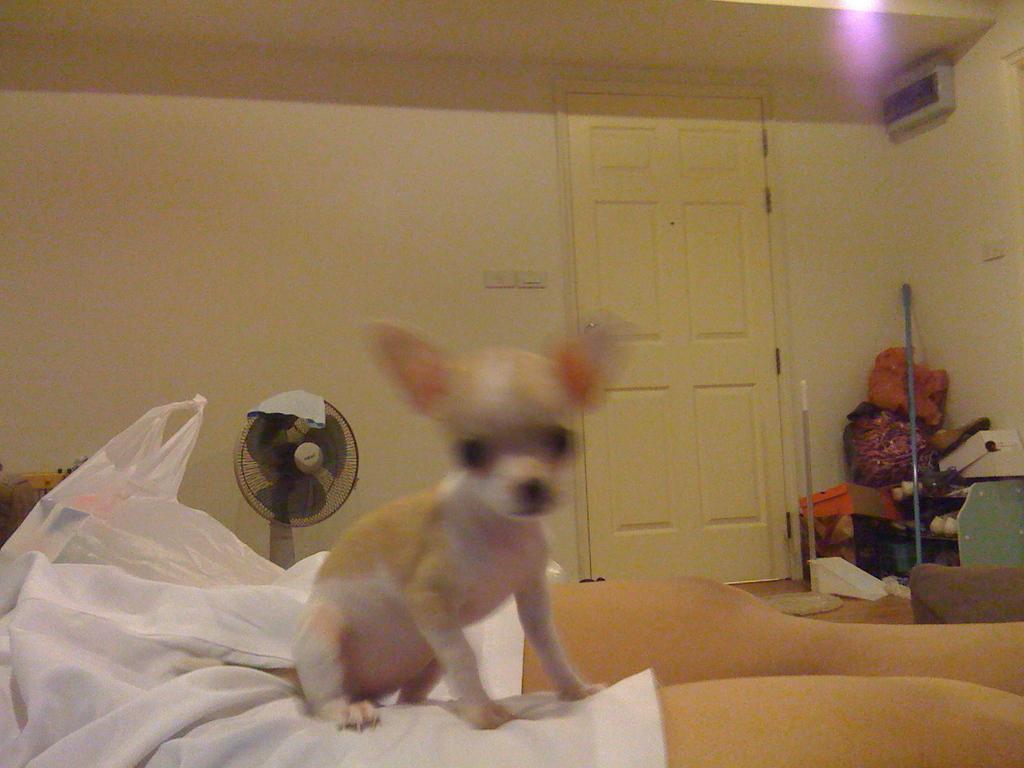Can you describe this image briefly? On the left side, there is a dog on a leg of a person who is wearing a white color short. Beside this person, there is a cover. In the background, there is a fan, a door, light attached to the roof, a wall and other objects on the floor. 